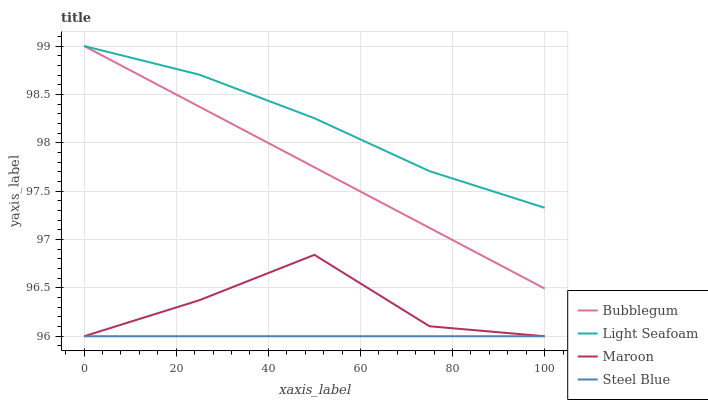Does Steel Blue have the minimum area under the curve?
Answer yes or no. Yes. Does Light Seafoam have the maximum area under the curve?
Answer yes or no. Yes. Does Maroon have the minimum area under the curve?
Answer yes or no. No. Does Maroon have the maximum area under the curve?
Answer yes or no. No. Is Steel Blue the smoothest?
Answer yes or no. Yes. Is Maroon the roughest?
Answer yes or no. Yes. Is Bubblegum the smoothest?
Answer yes or no. No. Is Bubblegum the roughest?
Answer yes or no. No. Does Maroon have the lowest value?
Answer yes or no. Yes. Does Bubblegum have the lowest value?
Answer yes or no. No. Does Bubblegum have the highest value?
Answer yes or no. Yes. Does Maroon have the highest value?
Answer yes or no. No. Is Maroon less than Light Seafoam?
Answer yes or no. Yes. Is Bubblegum greater than Maroon?
Answer yes or no. Yes. Does Maroon intersect Steel Blue?
Answer yes or no. Yes. Is Maroon less than Steel Blue?
Answer yes or no. No. Is Maroon greater than Steel Blue?
Answer yes or no. No. Does Maroon intersect Light Seafoam?
Answer yes or no. No. 